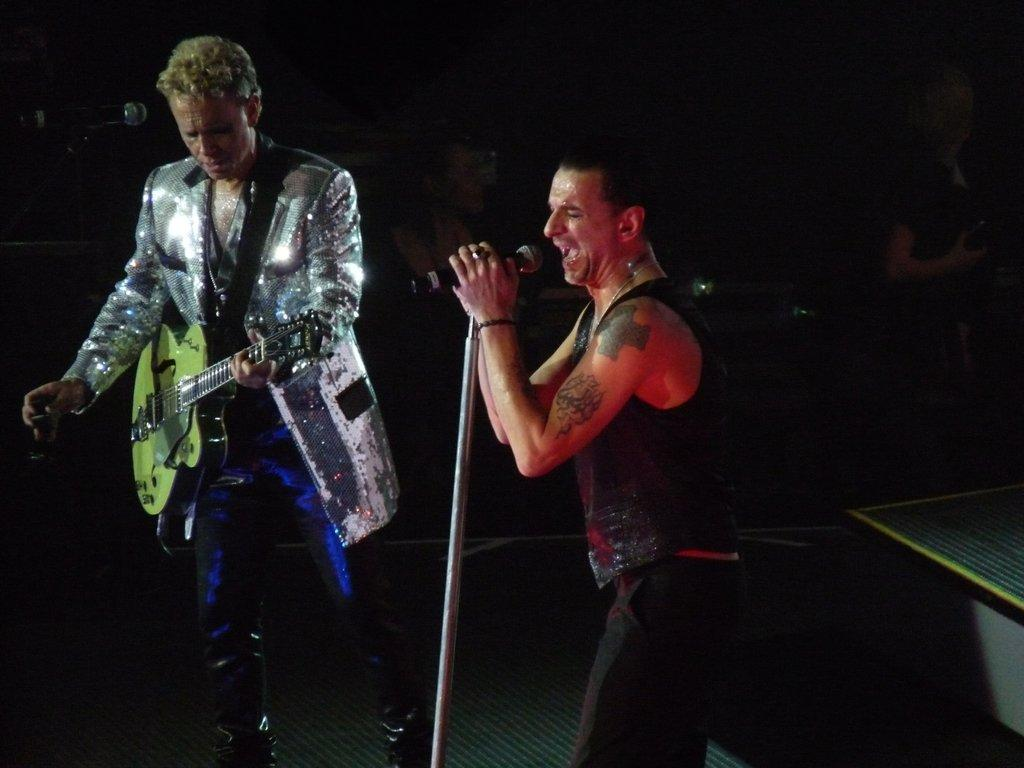How many men are present in the image? There are two men in the image. What is the man wearing a blazer holding? The man in the blazer is holding a guitar. What is the other man doing in the image? The other man is singing into a microphone. What can be observed about the background of the image? The background of the image is dark. Are there any other people visible in the image? Yes, there are additional people in the background. Is there a tendency for the guitar to produce a cobweb in the image? There is no mention of a cobweb in the image, and the guitar is not producing one. What type of animal can be seen interacting with the microphone in the image? There are no animals present in the image, and no animal is interacting with the microphone. 